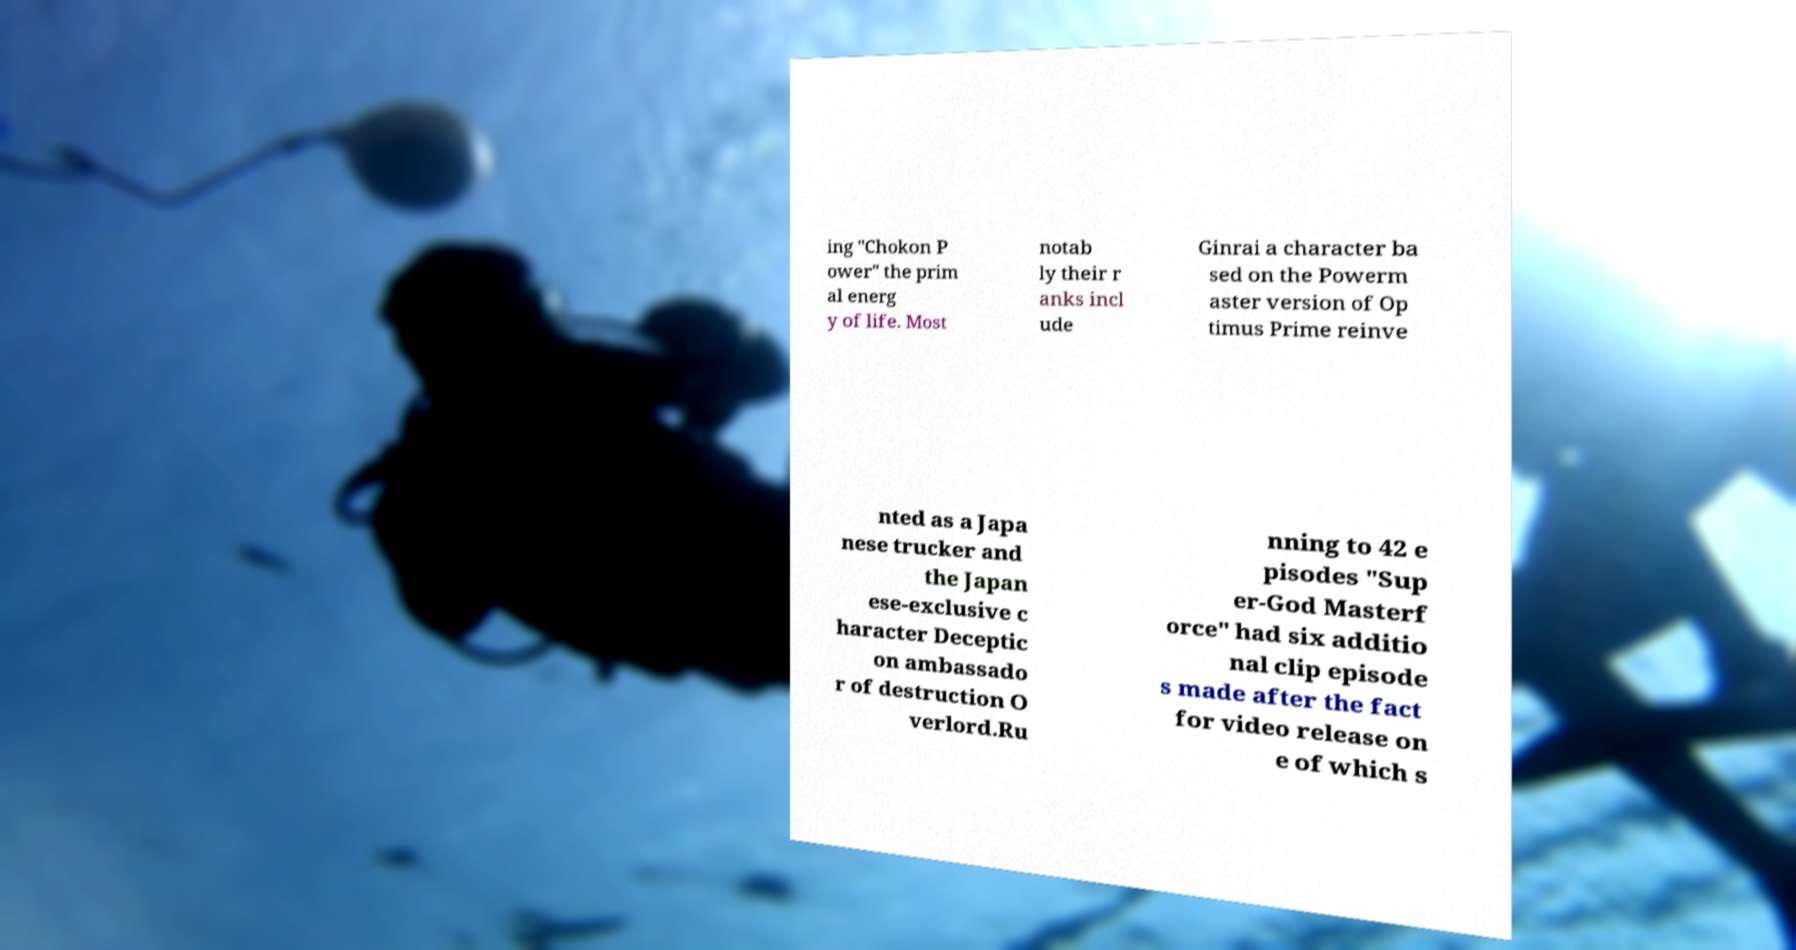For documentation purposes, I need the text within this image transcribed. Could you provide that? ing "Chokon P ower" the prim al energ y of life. Most notab ly their r anks incl ude Ginrai a character ba sed on the Powerm aster version of Op timus Prime reinve nted as a Japa nese trucker and the Japan ese-exclusive c haracter Deceptic on ambassado r of destruction O verlord.Ru nning to 42 e pisodes "Sup er-God Masterf orce" had six additio nal clip episode s made after the fact for video release on e of which s 